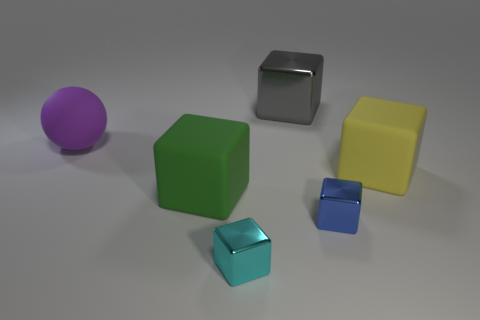Subtract 2 cubes. How many cubes are left? 3 Subtract all cyan blocks. How many blocks are left? 4 Subtract all gray blocks. How many blocks are left? 4 Subtract all brown blocks. Subtract all cyan cylinders. How many blocks are left? 5 Add 1 small brown metallic objects. How many objects exist? 7 Subtract all blocks. How many objects are left? 1 Add 2 tiny cyan metallic things. How many tiny cyan metallic things exist? 3 Subtract 0 red cubes. How many objects are left? 6 Subtract all yellow blocks. Subtract all cubes. How many objects are left? 0 Add 5 big shiny things. How many big shiny things are left? 6 